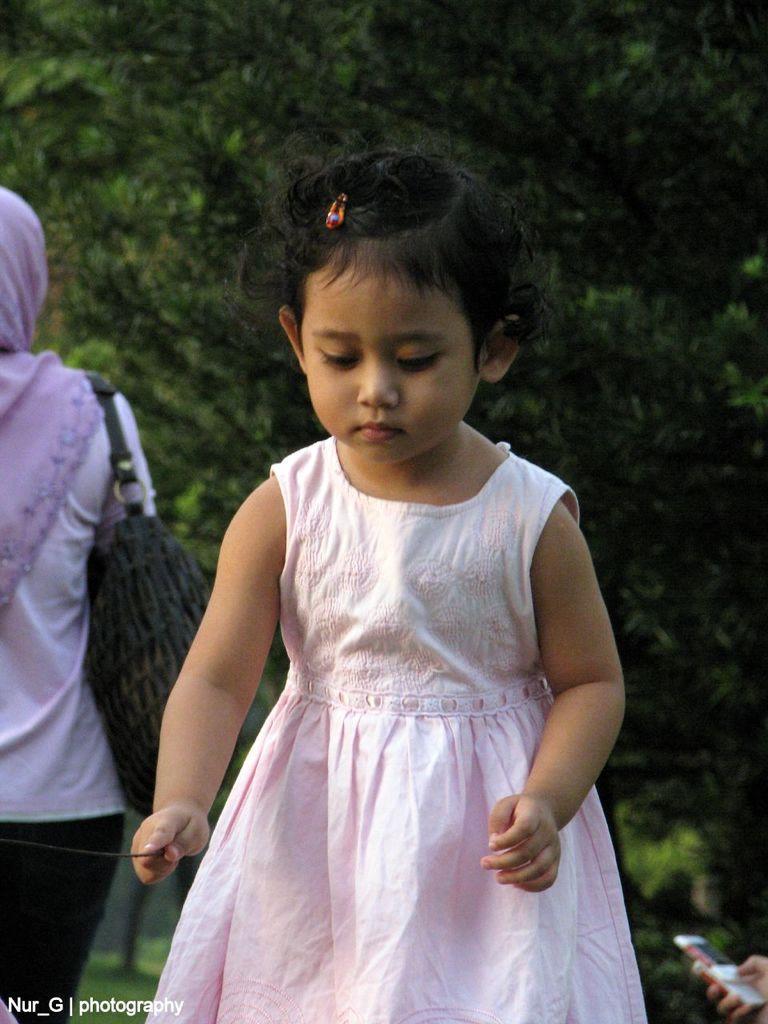Describe this image in one or two sentences. This image is taken outdoors. In the background there are a few trees and plants. On the left side of the image there is a woman. In the middle of the image there is a kid standing on the ground and she is holding a stick in her hand. On the right side of the image a person is holding a mobile in hand. 